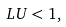Convert formula to latex. <formula><loc_0><loc_0><loc_500><loc_500>L U < 1 ,</formula> 